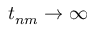<formula> <loc_0><loc_0><loc_500><loc_500>t _ { n m } \to \infty</formula> 